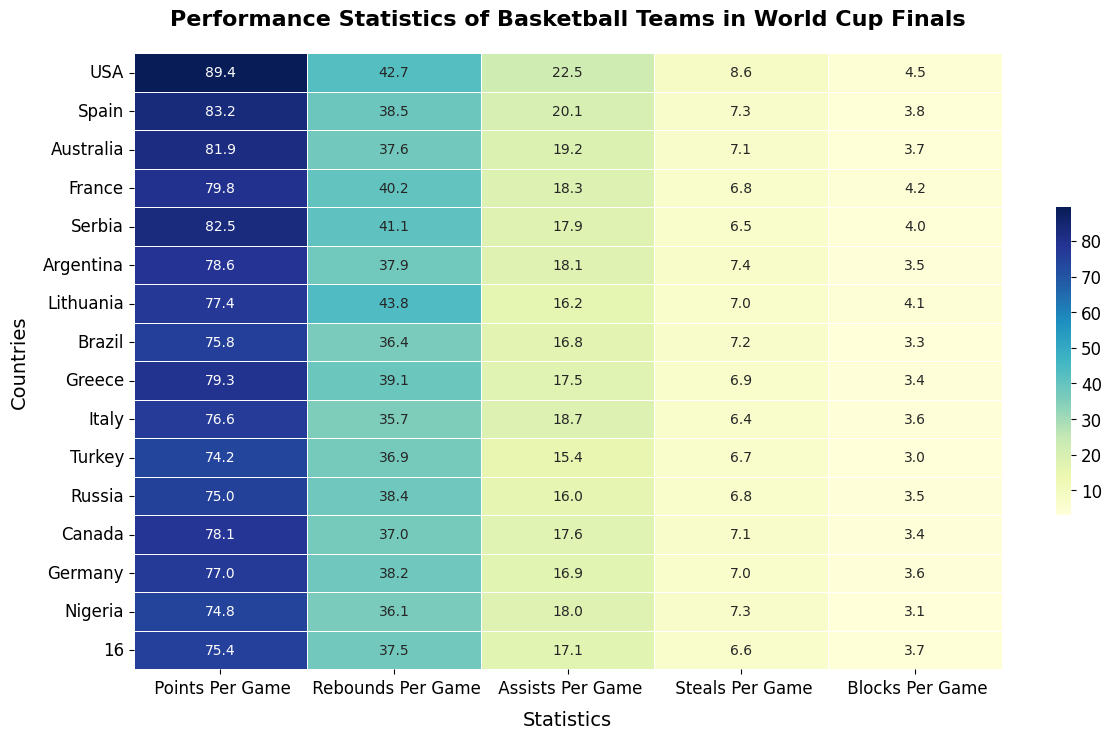Which country scores the most points per game? The heatmap shows "Points Per Game" for different countries. USA has the highest value, highlighted in the top left cell with 89.4 points per game.
Answer: USA Which country gets the most rebounds per game? The heatmap shows "Rebounds Per Game" for different countries. Lithuania has the highest value, highlighted with 43.8 rebounds per game.
Answer: Lithuania Compare the assists per game of Australia and Spain. Which country has more? By looking at the "Assists Per Game" column, Australia has 19.2, and Spain has 20.1 assists per game. Spain has more assists per game than Australia.
Answer: Spain What is the average points per game scored by Australia, France, and Serbia? Add the points per game for Australia (81.9), France (79.8), and Serbia (82.5) and then divide by 3. The calculation is (81.9 + 79.8 + 82.5)/3 = 81.4 points per game.
Answer: 81.4 Which country has the highest value for blocks per game, and what is that value? The "Blocks Per Game" column displays different values, and USA has the highest with 4.5 blocks per game.
Answer: USA, 4.5 Compare the total rebounds and blocks per game for Lithuania. What is the total? Lithuania has 43.8 rebounds per game and 4.1 blocks per game. The total is 43.8 + 4.1 = 47.9.
Answer: 47.9 What's the average steals per game for Greece, Nigeria, and Brazil? The steals per game are Greece (6.9), Nigeria (7.3), and Brazil (7.2). The average is (6.9 + 7.3 + 7.2)/3 = 7.13
Answer: 7.13 Which country has the lowest value for points per game, and what is that value? The "Points Per Game" column shows different values, with Turkey having the lowest value of 74.2 points per game.
Answer: Turkey, 74.2 How does the number of assists per game of Russia compare with that of Greece? Russia has 16.0 assists per game, while Greece has 17.5 assists per game. Thus, Greece has more assists per game than Russia.
Answer: Greece Which country has the least number of steals per game and what is that value? The "Steals Per Game" column shows different values, and Italy has the least number with 6.4 steals per game.
Answer: Italy, 6.4 